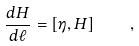<formula> <loc_0><loc_0><loc_500><loc_500>\frac { d H } { d \ell } = [ \eta , H ] \quad ,</formula> 